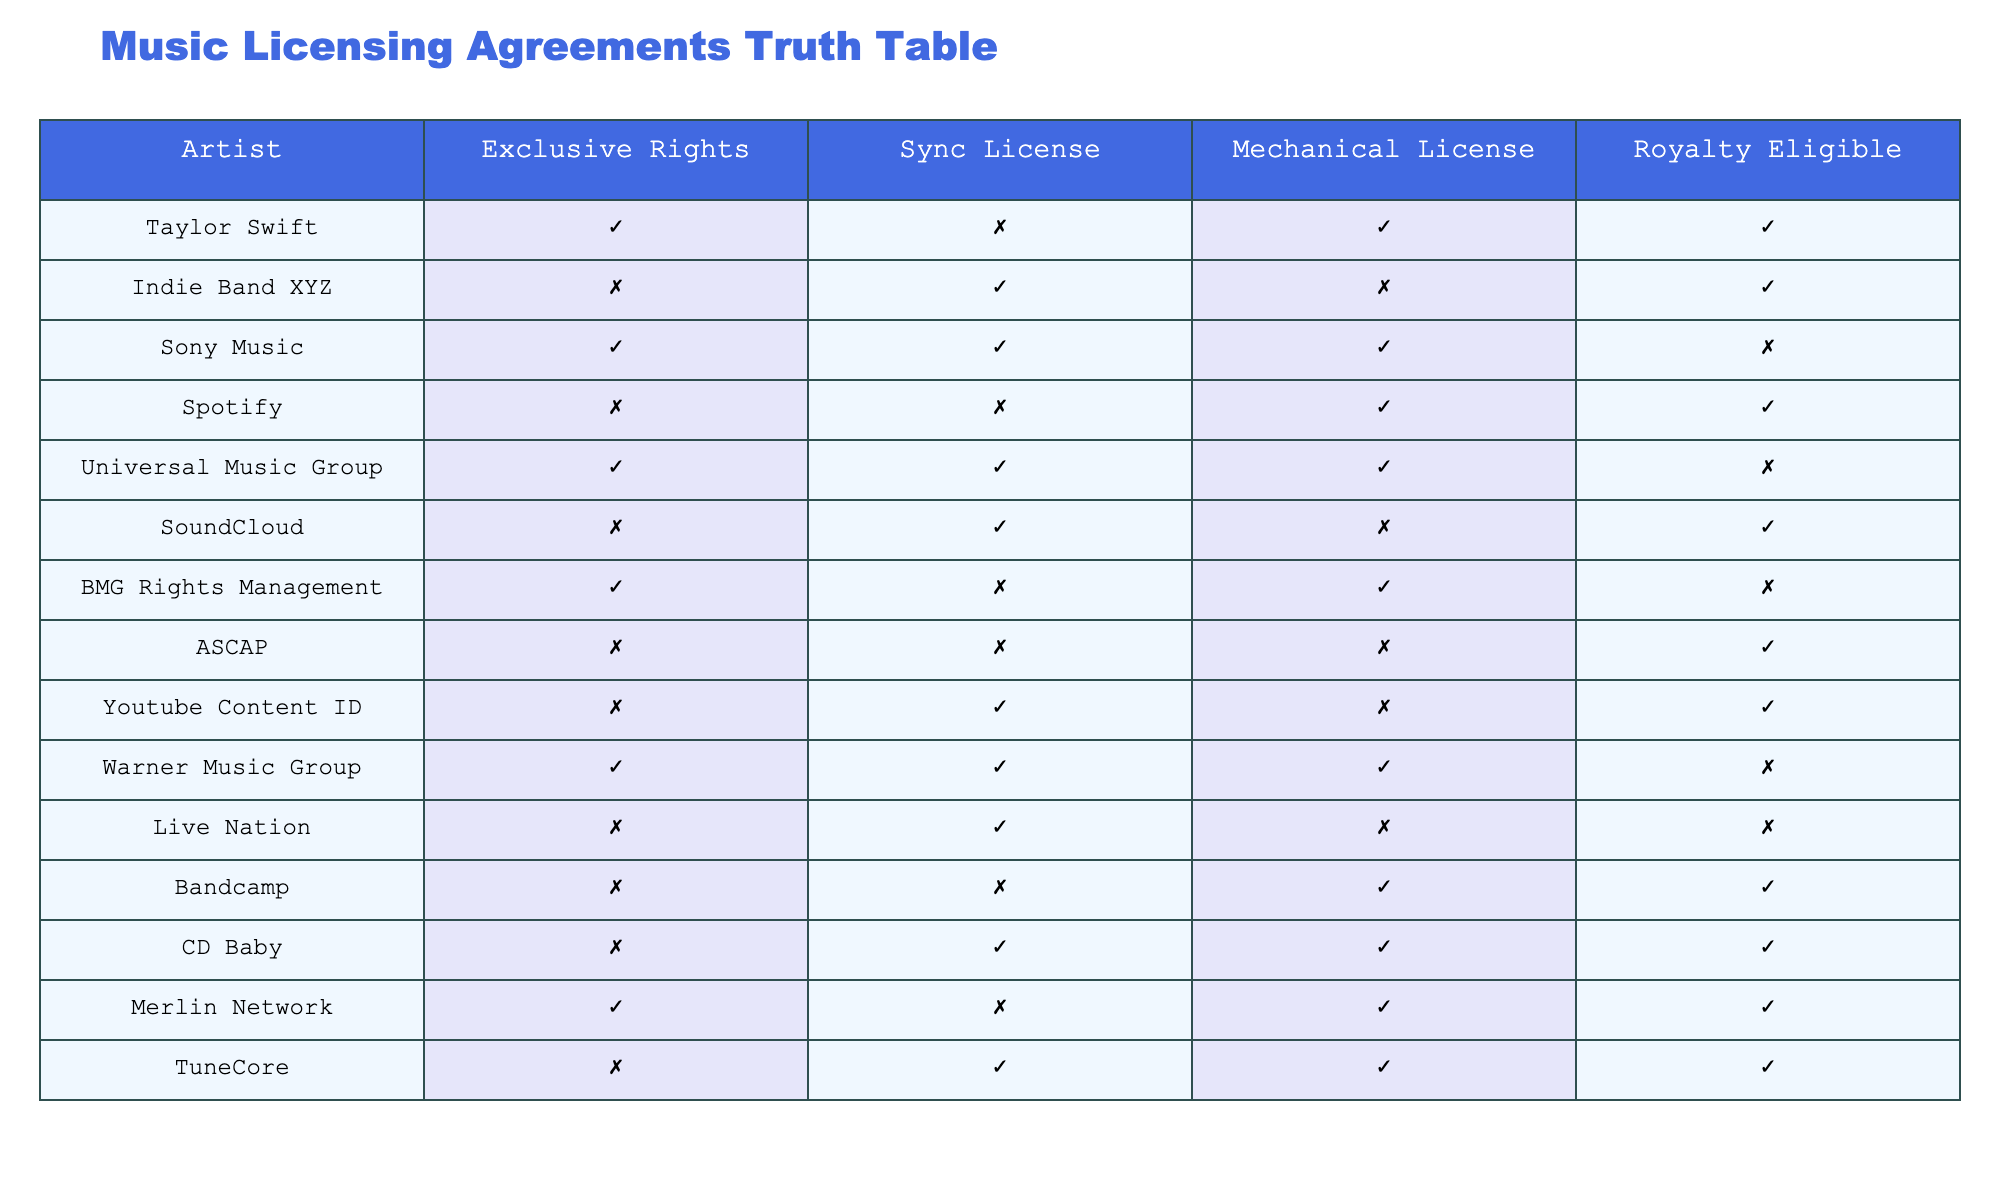What percentage of artists have exclusive rights? There are 7 entries with exclusive rights marked as true out of 15 total artists. To find the percentage, we calculate (7/15) * 100 = 46.67%.
Answer: 46.67% Does Indie Band XYZ have a mechanical license? In the table, Indie Band XYZ has a mechanical license marked as false. Therefore, they do not possess a mechanical license.
Answer: No Which artist has a sync license but is not royalty eligible? From the table, Sony Music and Universal Music Group have sync licenses marked as true, but neither is royalty eligible as both have false under the royalty eligible column.
Answer: Sony Music, Universal Music Group How many artists are royalty eligible but do not have exclusive rights? We need to count the artists who have royalty eligible marked as true and exclusive rights marked as false. The qualifying artists are Indie Band XYZ, Spotify, SoundCloud, ASCAP, Youtube Content ID, Bandcamp, CD Baby, and TuneCore, totaling 8 artists.
Answer: 8 Is BMG Rights Management exclusive to any licensing? The table shows that BMG Rights Management has exclusive rights marked as true, indicating that it is exclusive to some licensing.
Answer: Yes How many artists have both a sync license and a mechanical license? The artists with both sync and mechanical licenses are Sony Music, Spotify, and CD Baby. This gives a total of 3 artists having both licenses.
Answer: 3 Which artist has a mechanical license but does not have a sync license? The artist with a mechanical license who does not have a sync license is Bandcamp, as it is marked true for mechanical license and false for sync license.
Answer: Bandcamp How many artists are not royalty eligible with a sync license? The only artists not royalty eligible and have a sync license are Sony Music, Universal Music Group, and Warner Music Group, giving a total of 3.
Answer: 3 Is Live Nation entitled to any royalties based on the table? The table highlights that Live Nation is marked as false for royalty eligible, indicating it is not entitled to any royalties.
Answer: No 